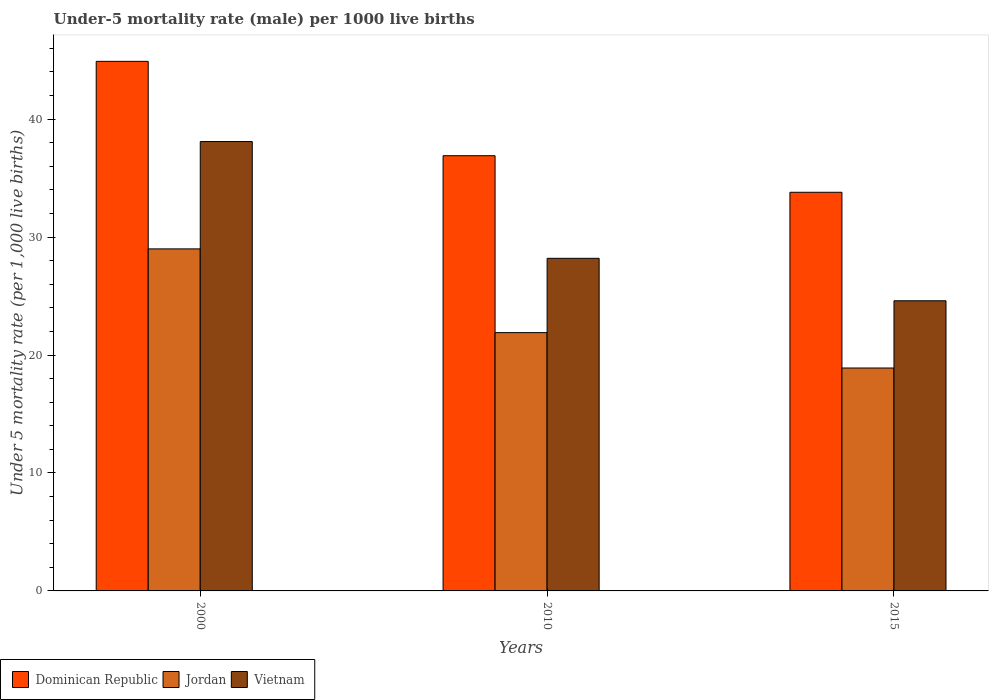How many different coloured bars are there?
Make the answer very short. 3. How many groups of bars are there?
Give a very brief answer. 3. Are the number of bars per tick equal to the number of legend labels?
Your response must be concise. Yes. Are the number of bars on each tick of the X-axis equal?
Your response must be concise. Yes. What is the label of the 3rd group of bars from the left?
Provide a succinct answer. 2015. In how many cases, is the number of bars for a given year not equal to the number of legend labels?
Your response must be concise. 0. What is the under-five mortality rate in Vietnam in 2015?
Keep it short and to the point. 24.6. Across all years, what is the maximum under-five mortality rate in Dominican Republic?
Give a very brief answer. 44.9. Across all years, what is the minimum under-five mortality rate in Dominican Republic?
Keep it short and to the point. 33.8. In which year was the under-five mortality rate in Vietnam minimum?
Your answer should be very brief. 2015. What is the total under-five mortality rate in Dominican Republic in the graph?
Offer a very short reply. 115.6. What is the difference between the under-five mortality rate in Jordan in 2000 and that in 2015?
Your answer should be very brief. 10.1. What is the difference between the under-five mortality rate in Jordan in 2010 and the under-five mortality rate in Dominican Republic in 2015?
Provide a succinct answer. -11.9. What is the average under-five mortality rate in Dominican Republic per year?
Provide a short and direct response. 38.53. In the year 2000, what is the difference between the under-five mortality rate in Jordan and under-five mortality rate in Dominican Republic?
Give a very brief answer. -15.9. In how many years, is the under-five mortality rate in Jordan greater than 28?
Provide a succinct answer. 1. What is the ratio of the under-five mortality rate in Jordan in 2000 to that in 2015?
Your answer should be very brief. 1.53. Is the under-five mortality rate in Vietnam in 2010 less than that in 2015?
Make the answer very short. No. What is the difference between the highest and the second highest under-five mortality rate in Vietnam?
Your answer should be very brief. 9.9. What is the difference between the highest and the lowest under-five mortality rate in Dominican Republic?
Give a very brief answer. 11.1. Is the sum of the under-five mortality rate in Vietnam in 2000 and 2015 greater than the maximum under-five mortality rate in Dominican Republic across all years?
Your answer should be very brief. Yes. What does the 3rd bar from the left in 2015 represents?
Make the answer very short. Vietnam. What does the 2nd bar from the right in 2010 represents?
Provide a succinct answer. Jordan. What is the difference between two consecutive major ticks on the Y-axis?
Offer a terse response. 10. Does the graph contain any zero values?
Ensure brevity in your answer.  No. Does the graph contain grids?
Your answer should be compact. No. What is the title of the graph?
Offer a terse response. Under-5 mortality rate (male) per 1000 live births. What is the label or title of the X-axis?
Provide a succinct answer. Years. What is the label or title of the Y-axis?
Offer a very short reply. Under 5 mortality rate (per 1,0 live births). What is the Under 5 mortality rate (per 1,000 live births) in Dominican Republic in 2000?
Ensure brevity in your answer.  44.9. What is the Under 5 mortality rate (per 1,000 live births) of Vietnam in 2000?
Provide a succinct answer. 38.1. What is the Under 5 mortality rate (per 1,000 live births) in Dominican Republic in 2010?
Ensure brevity in your answer.  36.9. What is the Under 5 mortality rate (per 1,000 live births) of Jordan in 2010?
Provide a short and direct response. 21.9. What is the Under 5 mortality rate (per 1,000 live births) of Vietnam in 2010?
Your answer should be compact. 28.2. What is the Under 5 mortality rate (per 1,000 live births) of Dominican Republic in 2015?
Make the answer very short. 33.8. What is the Under 5 mortality rate (per 1,000 live births) in Vietnam in 2015?
Provide a succinct answer. 24.6. Across all years, what is the maximum Under 5 mortality rate (per 1,000 live births) in Dominican Republic?
Provide a short and direct response. 44.9. Across all years, what is the maximum Under 5 mortality rate (per 1,000 live births) of Vietnam?
Keep it short and to the point. 38.1. Across all years, what is the minimum Under 5 mortality rate (per 1,000 live births) in Dominican Republic?
Provide a succinct answer. 33.8. Across all years, what is the minimum Under 5 mortality rate (per 1,000 live births) in Vietnam?
Make the answer very short. 24.6. What is the total Under 5 mortality rate (per 1,000 live births) of Dominican Republic in the graph?
Offer a terse response. 115.6. What is the total Under 5 mortality rate (per 1,000 live births) of Jordan in the graph?
Your answer should be very brief. 69.8. What is the total Under 5 mortality rate (per 1,000 live births) of Vietnam in the graph?
Your response must be concise. 90.9. What is the difference between the Under 5 mortality rate (per 1,000 live births) of Dominican Republic in 2000 and that in 2015?
Your answer should be very brief. 11.1. What is the difference between the Under 5 mortality rate (per 1,000 live births) of Vietnam in 2000 and that in 2015?
Offer a terse response. 13.5. What is the difference between the Under 5 mortality rate (per 1,000 live births) of Dominican Republic in 2010 and that in 2015?
Your answer should be compact. 3.1. What is the difference between the Under 5 mortality rate (per 1,000 live births) in Dominican Republic in 2000 and the Under 5 mortality rate (per 1,000 live births) in Vietnam in 2010?
Ensure brevity in your answer.  16.7. What is the difference between the Under 5 mortality rate (per 1,000 live births) of Dominican Republic in 2000 and the Under 5 mortality rate (per 1,000 live births) of Jordan in 2015?
Keep it short and to the point. 26. What is the difference between the Under 5 mortality rate (per 1,000 live births) of Dominican Republic in 2000 and the Under 5 mortality rate (per 1,000 live births) of Vietnam in 2015?
Provide a succinct answer. 20.3. What is the difference between the Under 5 mortality rate (per 1,000 live births) in Jordan in 2000 and the Under 5 mortality rate (per 1,000 live births) in Vietnam in 2015?
Your response must be concise. 4.4. What is the average Under 5 mortality rate (per 1,000 live births) of Dominican Republic per year?
Offer a very short reply. 38.53. What is the average Under 5 mortality rate (per 1,000 live births) in Jordan per year?
Provide a succinct answer. 23.27. What is the average Under 5 mortality rate (per 1,000 live births) of Vietnam per year?
Give a very brief answer. 30.3. In the year 2000, what is the difference between the Under 5 mortality rate (per 1,000 live births) of Dominican Republic and Under 5 mortality rate (per 1,000 live births) of Jordan?
Offer a very short reply. 15.9. In the year 2000, what is the difference between the Under 5 mortality rate (per 1,000 live births) in Jordan and Under 5 mortality rate (per 1,000 live births) in Vietnam?
Provide a succinct answer. -9.1. In the year 2010, what is the difference between the Under 5 mortality rate (per 1,000 live births) of Jordan and Under 5 mortality rate (per 1,000 live births) of Vietnam?
Provide a short and direct response. -6.3. In the year 2015, what is the difference between the Under 5 mortality rate (per 1,000 live births) in Dominican Republic and Under 5 mortality rate (per 1,000 live births) in Jordan?
Offer a terse response. 14.9. In the year 2015, what is the difference between the Under 5 mortality rate (per 1,000 live births) in Jordan and Under 5 mortality rate (per 1,000 live births) in Vietnam?
Give a very brief answer. -5.7. What is the ratio of the Under 5 mortality rate (per 1,000 live births) in Dominican Republic in 2000 to that in 2010?
Provide a succinct answer. 1.22. What is the ratio of the Under 5 mortality rate (per 1,000 live births) in Jordan in 2000 to that in 2010?
Give a very brief answer. 1.32. What is the ratio of the Under 5 mortality rate (per 1,000 live births) of Vietnam in 2000 to that in 2010?
Provide a short and direct response. 1.35. What is the ratio of the Under 5 mortality rate (per 1,000 live births) of Dominican Republic in 2000 to that in 2015?
Your answer should be compact. 1.33. What is the ratio of the Under 5 mortality rate (per 1,000 live births) of Jordan in 2000 to that in 2015?
Provide a short and direct response. 1.53. What is the ratio of the Under 5 mortality rate (per 1,000 live births) in Vietnam in 2000 to that in 2015?
Provide a succinct answer. 1.55. What is the ratio of the Under 5 mortality rate (per 1,000 live births) in Dominican Republic in 2010 to that in 2015?
Give a very brief answer. 1.09. What is the ratio of the Under 5 mortality rate (per 1,000 live births) of Jordan in 2010 to that in 2015?
Your answer should be compact. 1.16. What is the ratio of the Under 5 mortality rate (per 1,000 live births) in Vietnam in 2010 to that in 2015?
Provide a short and direct response. 1.15. What is the difference between the highest and the second highest Under 5 mortality rate (per 1,000 live births) in Dominican Republic?
Your answer should be very brief. 8. What is the difference between the highest and the second highest Under 5 mortality rate (per 1,000 live births) of Vietnam?
Your answer should be compact. 9.9. What is the difference between the highest and the lowest Under 5 mortality rate (per 1,000 live births) in Jordan?
Your response must be concise. 10.1. What is the difference between the highest and the lowest Under 5 mortality rate (per 1,000 live births) in Vietnam?
Make the answer very short. 13.5. 